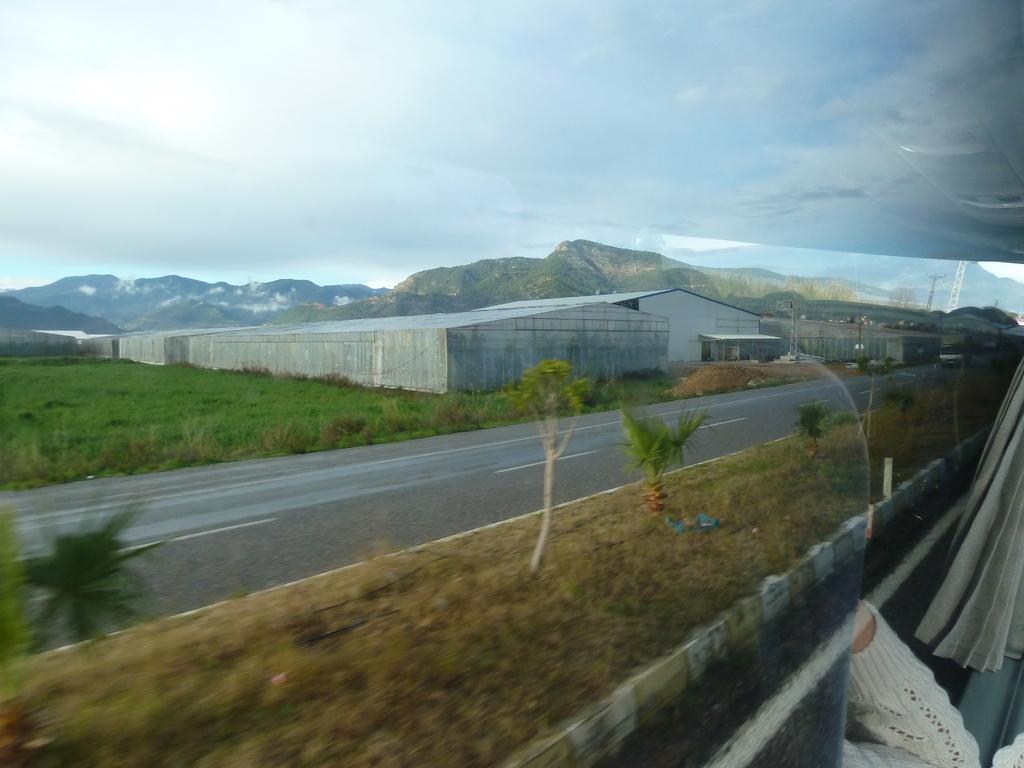How would you summarize this image in a sentence or two? In this picture there is a vehicle on the road and there is a poultry farm,greenery ground and mountains in the background and there is a hand of a person in the right corner. 